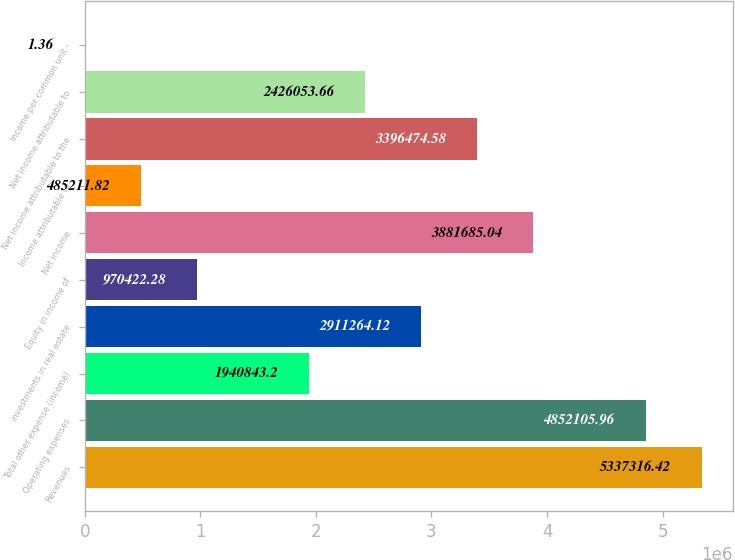Convert chart to OTSL. <chart><loc_0><loc_0><loc_500><loc_500><bar_chart><fcel>Revenues<fcel>Operating expenses<fcel>Total other expense (income)<fcel>investments in real estate<fcel>Equity in income of<fcel>Net income<fcel>Income attributable to<fcel>Net income attributable to the<fcel>Net income attributable to<fcel>Income per common unit -<nl><fcel>5.33732e+06<fcel>4.85211e+06<fcel>1.94084e+06<fcel>2.91126e+06<fcel>970422<fcel>3.88169e+06<fcel>485212<fcel>3.39647e+06<fcel>2.42605e+06<fcel>1.36<nl></chart> 